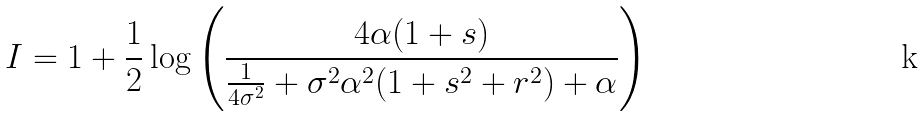<formula> <loc_0><loc_0><loc_500><loc_500>I = 1 + \frac { 1 } { 2 } \log \left ( \frac { 4 \alpha ( 1 + s ) } { \frac { 1 } { 4 \sigma ^ { 2 } } + \sigma ^ { 2 } \alpha ^ { 2 } ( 1 + s ^ { 2 } + r ^ { 2 } ) + \alpha } \right )</formula> 